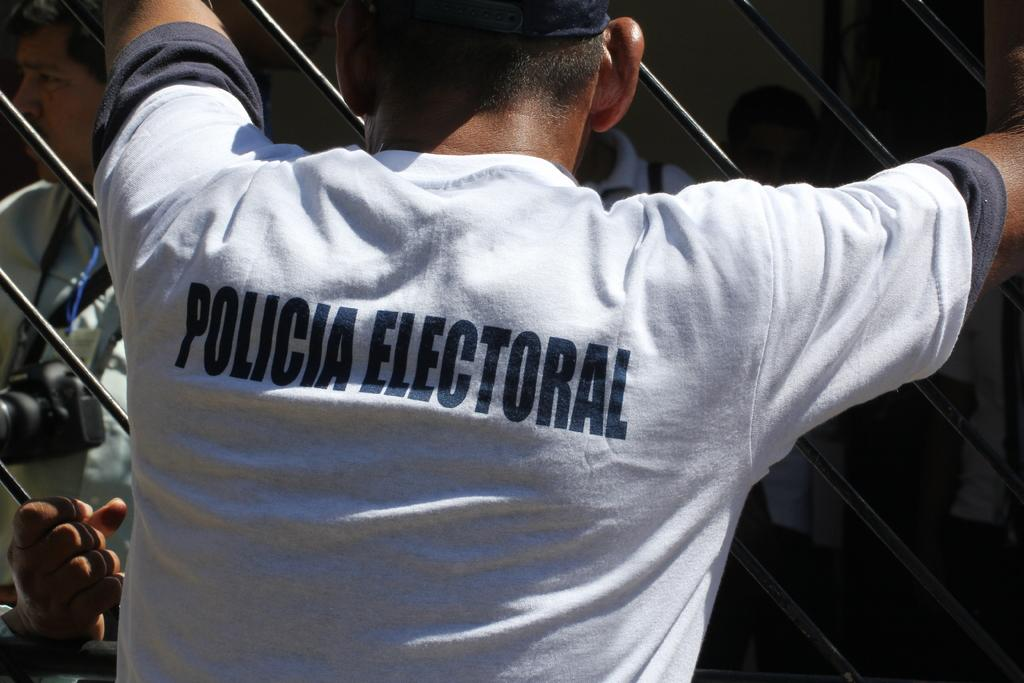<image>
Create a compact narrative representing the image presented. Man wearing a white shirt which says Policia. 